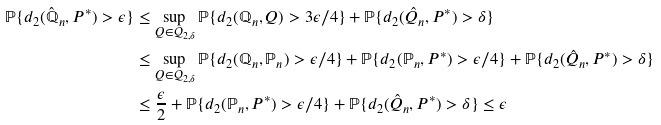Convert formula to latex. <formula><loc_0><loc_0><loc_500><loc_500>\mathbb { P } \{ d _ { 2 } ( \hat { \mathbb { Q } } _ { n } , P ^ { * } ) > \epsilon \} & \leq \sup _ { Q \in \mathcal { Q } _ { 2 , \delta } } \mathbb { P } \{ d _ { 2 } ( \mathbb { Q } _ { n } , Q ) > 3 \epsilon / 4 \} + \mathbb { P } \{ d _ { 2 } ( \hat { Q } _ { n } , P ^ { * } ) > \delta \} \\ & \leq \sup _ { Q \in \mathcal { Q } _ { 2 , \delta } } \mathbb { P } \{ d _ { 2 } ( \mathbb { Q } _ { n } , \mathbb { P } _ { n } ) > \epsilon / 4 \} + \mathbb { P } \{ d _ { 2 } ( \mathbb { P } _ { n } , P ^ { * } ) > \epsilon / 4 \} + \mathbb { P } \{ d _ { 2 } ( \hat { Q } _ { n } , P ^ { * } ) > \delta \} \\ & \leq \frac { \epsilon } { 2 } + \mathbb { P } \{ d _ { 2 } ( \mathbb { P } _ { n } , P ^ { * } ) > \epsilon / 4 \} + \mathbb { P } \{ d _ { 2 } ( \hat { Q } _ { n } , P ^ { * } ) > \delta \} \leq \epsilon</formula> 